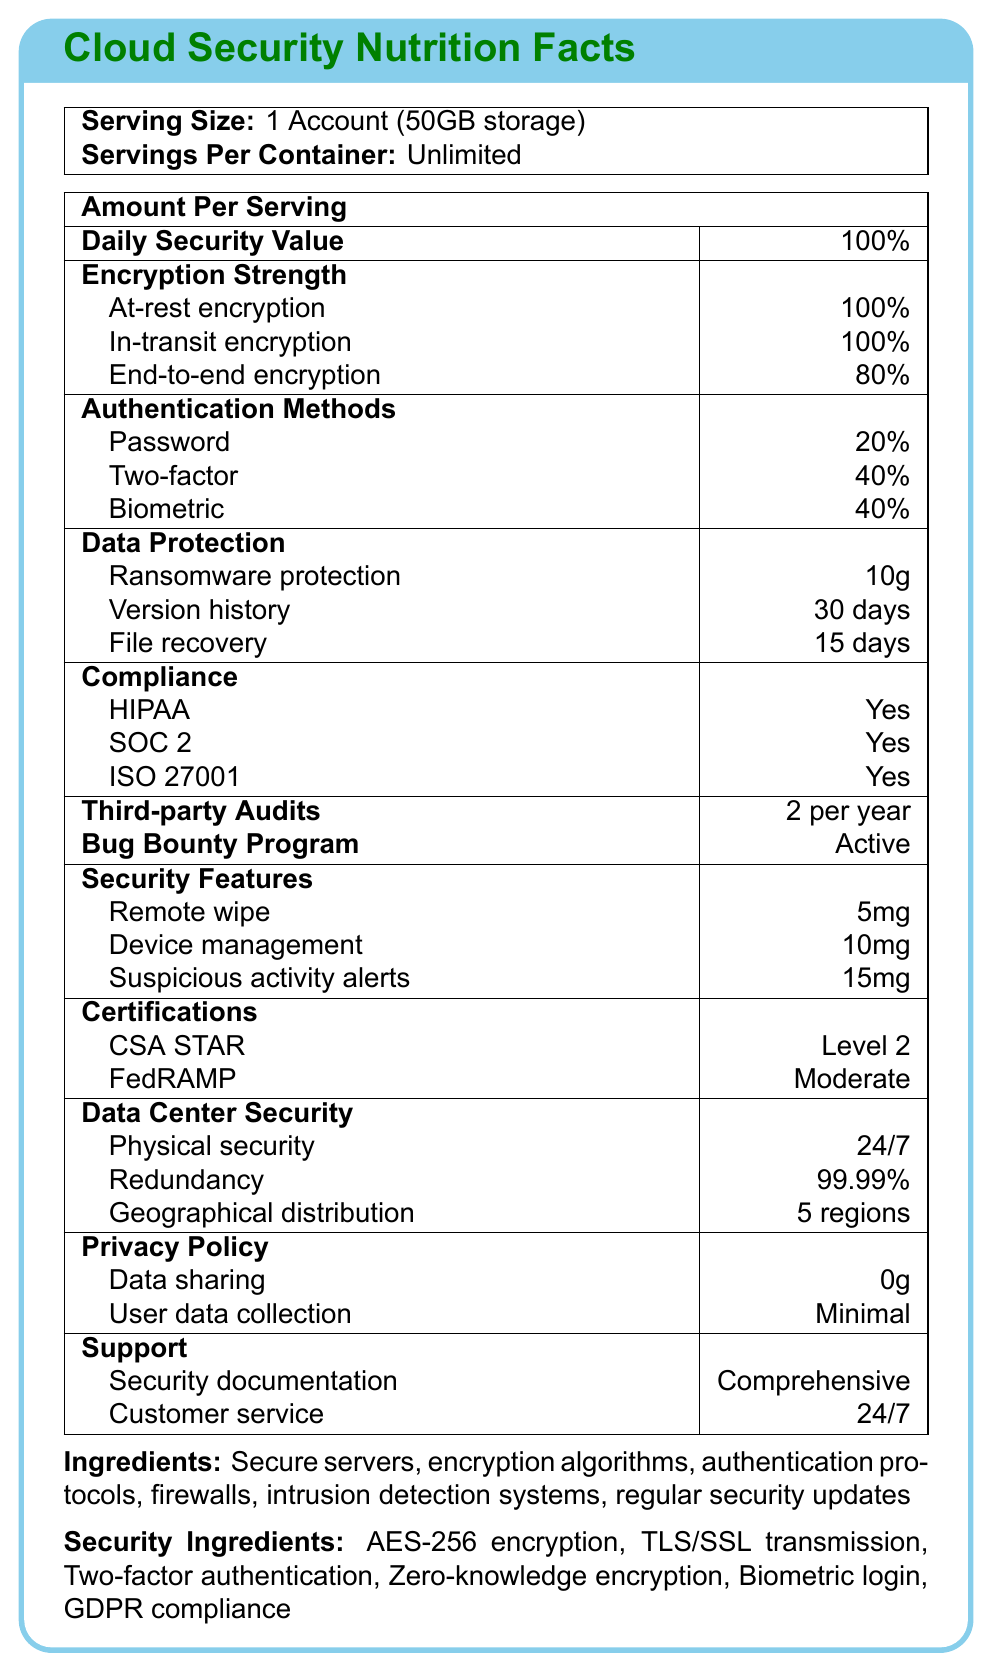What is the serving size described in the document? The document states that the serving size is "1 Account (50GB storage)".
Answer: 1 Account (50GB storage) How many servings are there per container? The document mentions that there are "Unlimited" servings per container.
Answer: Unlimited What percentage of Daily Security Value does the cloud storage service provide? The document specifies that the Daily Security Value is 100%.
Answer: 100% What encryption methods are mentioned in the Security Ingredients? The Security Ingredients list these methods.
Answer: AES-256 encryption, TLS/SSL transmission, Two-factor authentication, Zero-knowledge encryption, Biometric login, GDPR compliance How often are third-party audits conducted? The document states that third-party audits are conducted "2 per year".
Answer: 2 per year Which of the following is not mentioned as an Authentication Method? A. Password B. Two-factor authentication C. Single sign-on (SSO) D. Biometric login The Authentication Methods listed are Password, Two-factor authentication, and Biometric login. Single sign-on (SSO) is not mentioned.
Answer: C. Single sign-on (SSO) What is the level of CSA STAR certification attained by the service? A. Level 1 B. Level 2 C. Level 3 D. Level 4 The document mentions that the service has achieved "Level 2" CSA STAR certification.
Answer: B. Level 2 Is the service GDPR compliant? The document states "GDPR compliance" under Security Ingredients, indicating the service is GDPR compliant.
Answer: Yes Summarize the main focus of the document. The document outlines the security measures and compliance standards of the cloud storage service, presenting information on encryption strength, authentication methods, and various certifications.
Answer: The document provides an overview of the security features and compliance certifications of a cloud storage service. It includes details on encryption, authentication methods, data protection, compliance, audits, and other security features. What amount of data is shared according to the Privacy Policy? The document specifies "Data sharing: 0g" under the Privacy Policy section.
Answer: 0g What is the redundancy rate for data center security? The document lists "Redundancy: 99.99%" under Data Center Security.
Answer: 99.99% How active is the Bug Bounty Program? A. Inactive B. Limited C. Active D. Sporadic The document states that the Bug Bounty Program is "Active".
Answer: C. Active What is the percentage of end-to-end encryption? The document shows that end-to-end encryption is at 80%.
Answer: 80% What is the duration for file recovery available to users? The document mentions "File recovery: 15 days" under Data Protection.
Answer: 15 days Are the encryption algorithms specified in the document? The document lists several encryption algorithms in the "Security Ingredients" such as AES-256 encryption and TLS/SSL transmission.
Answer: Yes Can the exact date of the last third-party audit be determined from the document? The document only states the frequency of audits (2 per year) but does not provide exact dates.
Answer: Not enough information 